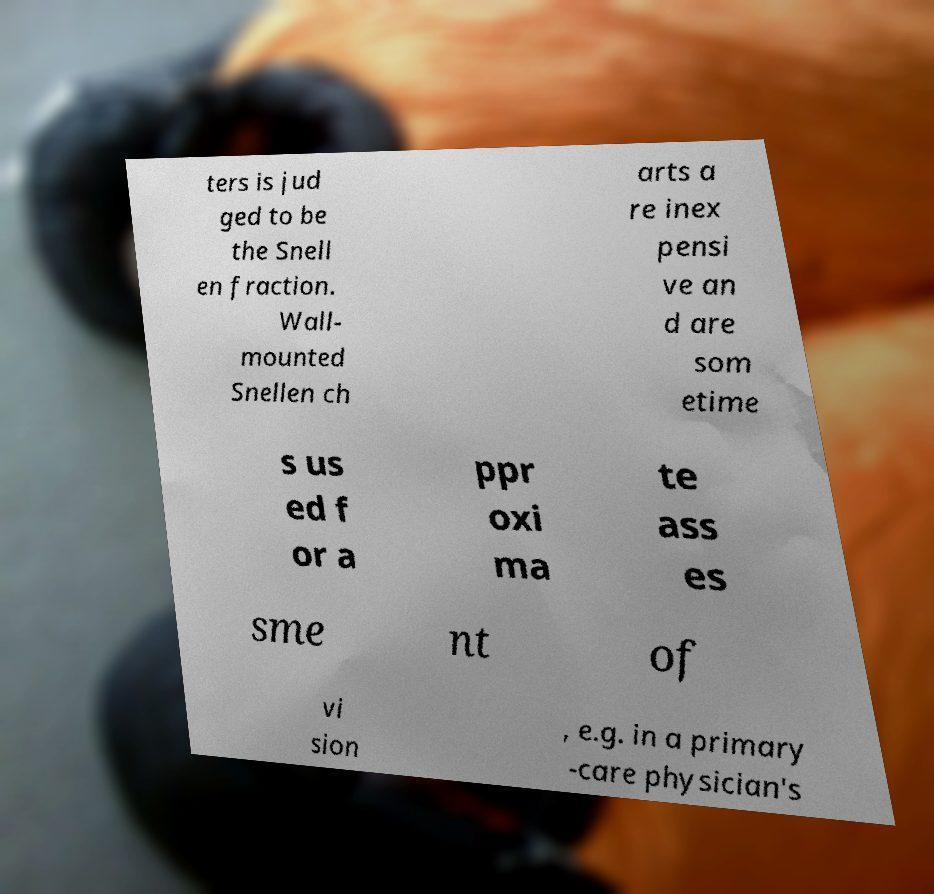There's text embedded in this image that I need extracted. Can you transcribe it verbatim? ters is jud ged to be the Snell en fraction. Wall- mounted Snellen ch arts a re inex pensi ve an d are som etime s us ed f or a ppr oxi ma te ass es sme nt of vi sion , e.g. in a primary -care physician's 